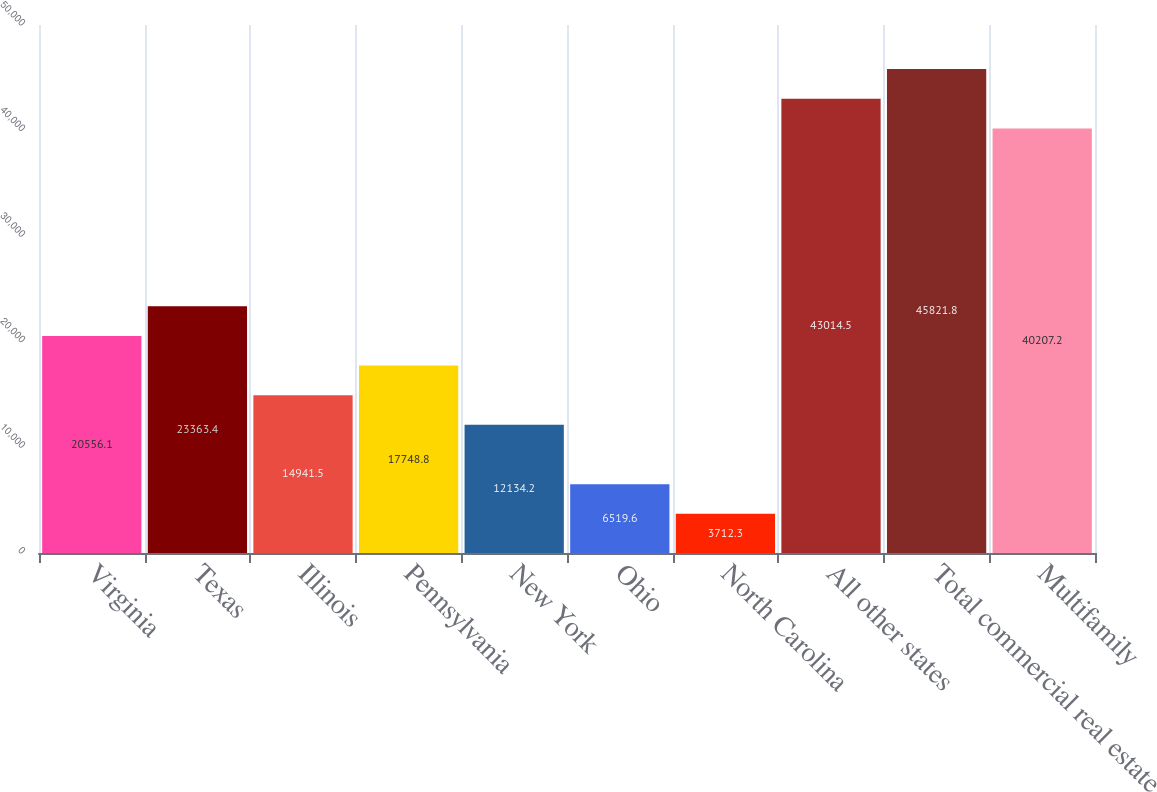<chart> <loc_0><loc_0><loc_500><loc_500><bar_chart><fcel>Virginia<fcel>Texas<fcel>Illinois<fcel>Pennsylvania<fcel>New York<fcel>Ohio<fcel>North Carolina<fcel>All other states<fcel>Total commercial real estate<fcel>Multifamily<nl><fcel>20556.1<fcel>23363.4<fcel>14941.5<fcel>17748.8<fcel>12134.2<fcel>6519.6<fcel>3712.3<fcel>43014.5<fcel>45821.8<fcel>40207.2<nl></chart> 